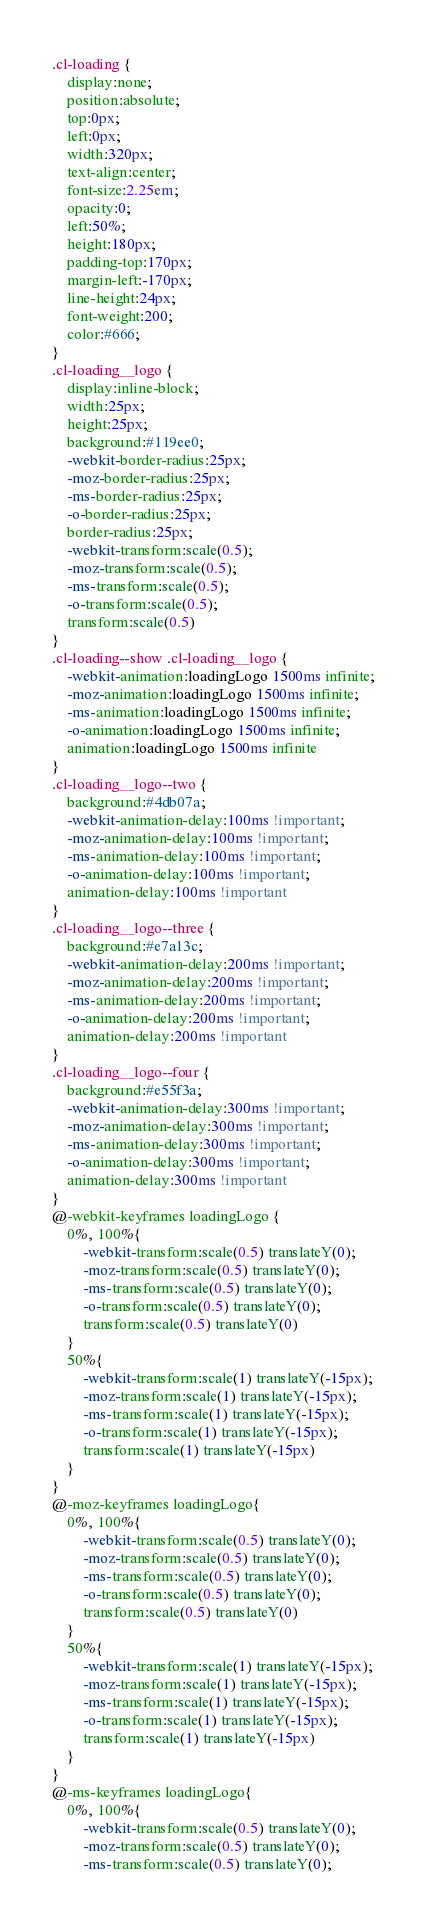<code> <loc_0><loc_0><loc_500><loc_500><_CSS_>.cl-loading {
    display:none;
    position:absolute;
    top:0px;
    left:0px;
    width:320px;
    text-align:center;
    font-size:2.25em;
    opacity:0;
    left:50%;
    height:180px;
    padding-top:170px;
    margin-left:-170px;
    line-height:24px;
    font-weight:200;
    color:#666;
}
.cl-loading__logo {
    display:inline-block;
    width:25px;
    height:25px;
    background:#119ee0;
    -webkit-border-radius:25px;
    -moz-border-radius:25px;
    -ms-border-radius:25px;
    -o-border-radius:25px;
    border-radius:25px;
    -webkit-transform:scale(0.5);
    -moz-transform:scale(0.5);
    -ms-transform:scale(0.5);
    -o-transform:scale(0.5);
    transform:scale(0.5)
}
.cl-loading--show .cl-loading__logo {
    -webkit-animation:loadingLogo 1500ms infinite;
    -moz-animation:loadingLogo 1500ms infinite;
    -ms-animation:loadingLogo 1500ms infinite;
    -o-animation:loadingLogo 1500ms infinite;
    animation:loadingLogo 1500ms infinite
}
.cl-loading__logo--two {
    background:#4db07a;
    -webkit-animation-delay:100ms !important;
    -moz-animation-delay:100ms !important;
    -ms-animation-delay:100ms !important;
    -o-animation-delay:100ms !important;
    animation-delay:100ms !important
}
.cl-loading__logo--three {
    background:#e7a13c;
    -webkit-animation-delay:200ms !important;
    -moz-animation-delay:200ms !important;
    -ms-animation-delay:200ms !important;
    -o-animation-delay:200ms !important;
    animation-delay:200ms !important
}
.cl-loading__logo--four {
    background:#e55f3a;
    -webkit-animation-delay:300ms !important;
    -moz-animation-delay:300ms !important;
    -ms-animation-delay:300ms !important;
    -o-animation-delay:300ms !important;
    animation-delay:300ms !important
}
@-webkit-keyframes loadingLogo {
    0%, 100%{
        -webkit-transform:scale(0.5) translateY(0);
        -moz-transform:scale(0.5) translateY(0);
        -ms-transform:scale(0.5) translateY(0);
        -o-transform:scale(0.5) translateY(0);
        transform:scale(0.5) translateY(0)
    }
    50%{
        -webkit-transform:scale(1) translateY(-15px);
        -moz-transform:scale(1) translateY(-15px);
        -ms-transform:scale(1) translateY(-15px);
        -o-transform:scale(1) translateY(-15px);
        transform:scale(1) translateY(-15px)
    }
}
@-moz-keyframes loadingLogo{
    0%, 100%{
        -webkit-transform:scale(0.5) translateY(0);
        -moz-transform:scale(0.5) translateY(0);
        -ms-transform:scale(0.5) translateY(0);
        -o-transform:scale(0.5) translateY(0);
        transform:scale(0.5) translateY(0)
    }
    50%{
        -webkit-transform:scale(1) translateY(-15px);
        -moz-transform:scale(1) translateY(-15px);
        -ms-transform:scale(1) translateY(-15px);
        -o-transform:scale(1) translateY(-15px);
        transform:scale(1) translateY(-15px)
    }
}
@-ms-keyframes loadingLogo{
    0%, 100%{
        -webkit-transform:scale(0.5) translateY(0);
        -moz-transform:scale(0.5) translateY(0);
        -ms-transform:scale(0.5) translateY(0);</code> 